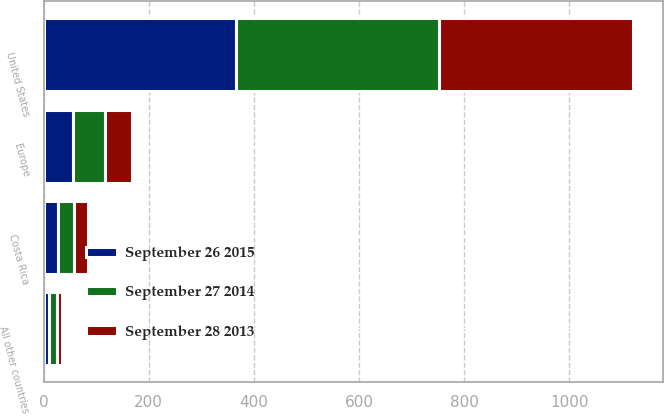Convert chart. <chart><loc_0><loc_0><loc_500><loc_500><stacked_bar_chart><ecel><fcel>United States<fcel>Costa Rica<fcel>Europe<fcel>All other countries<nl><fcel>September 28 2013<fcel>369.1<fcel>27.7<fcel>50.8<fcel>9.5<nl><fcel>September 26 2015<fcel>366.8<fcel>27.9<fcel>56<fcel>11.2<nl><fcel>September 27 2014<fcel>386<fcel>29.3<fcel>61.5<fcel>14.7<nl></chart> 